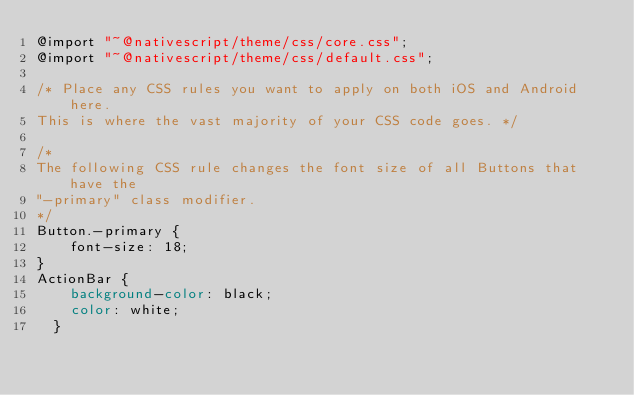Convert code to text. <code><loc_0><loc_0><loc_500><loc_500><_CSS_>@import "~@nativescript/theme/css/core.css";
@import "~@nativescript/theme/css/default.css";

/* Place any CSS rules you want to apply on both iOS and Android here.
This is where the vast majority of your CSS code goes. */

/*
The following CSS rule changes the font size of all Buttons that have the
"-primary" class modifier.
*/
Button.-primary {
    font-size: 18;
}
ActionBar {
    background-color: black;
    color: white;
  }
</code> 